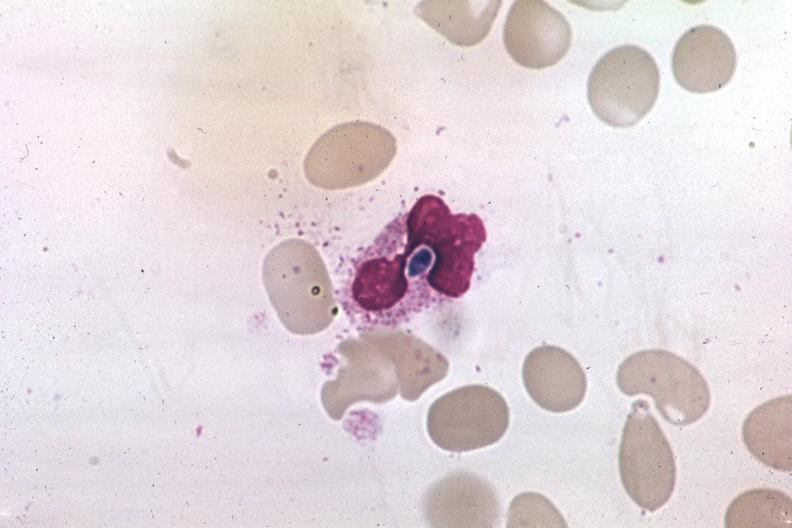s villous adenoma present?
Answer the question using a single word or phrase. No 